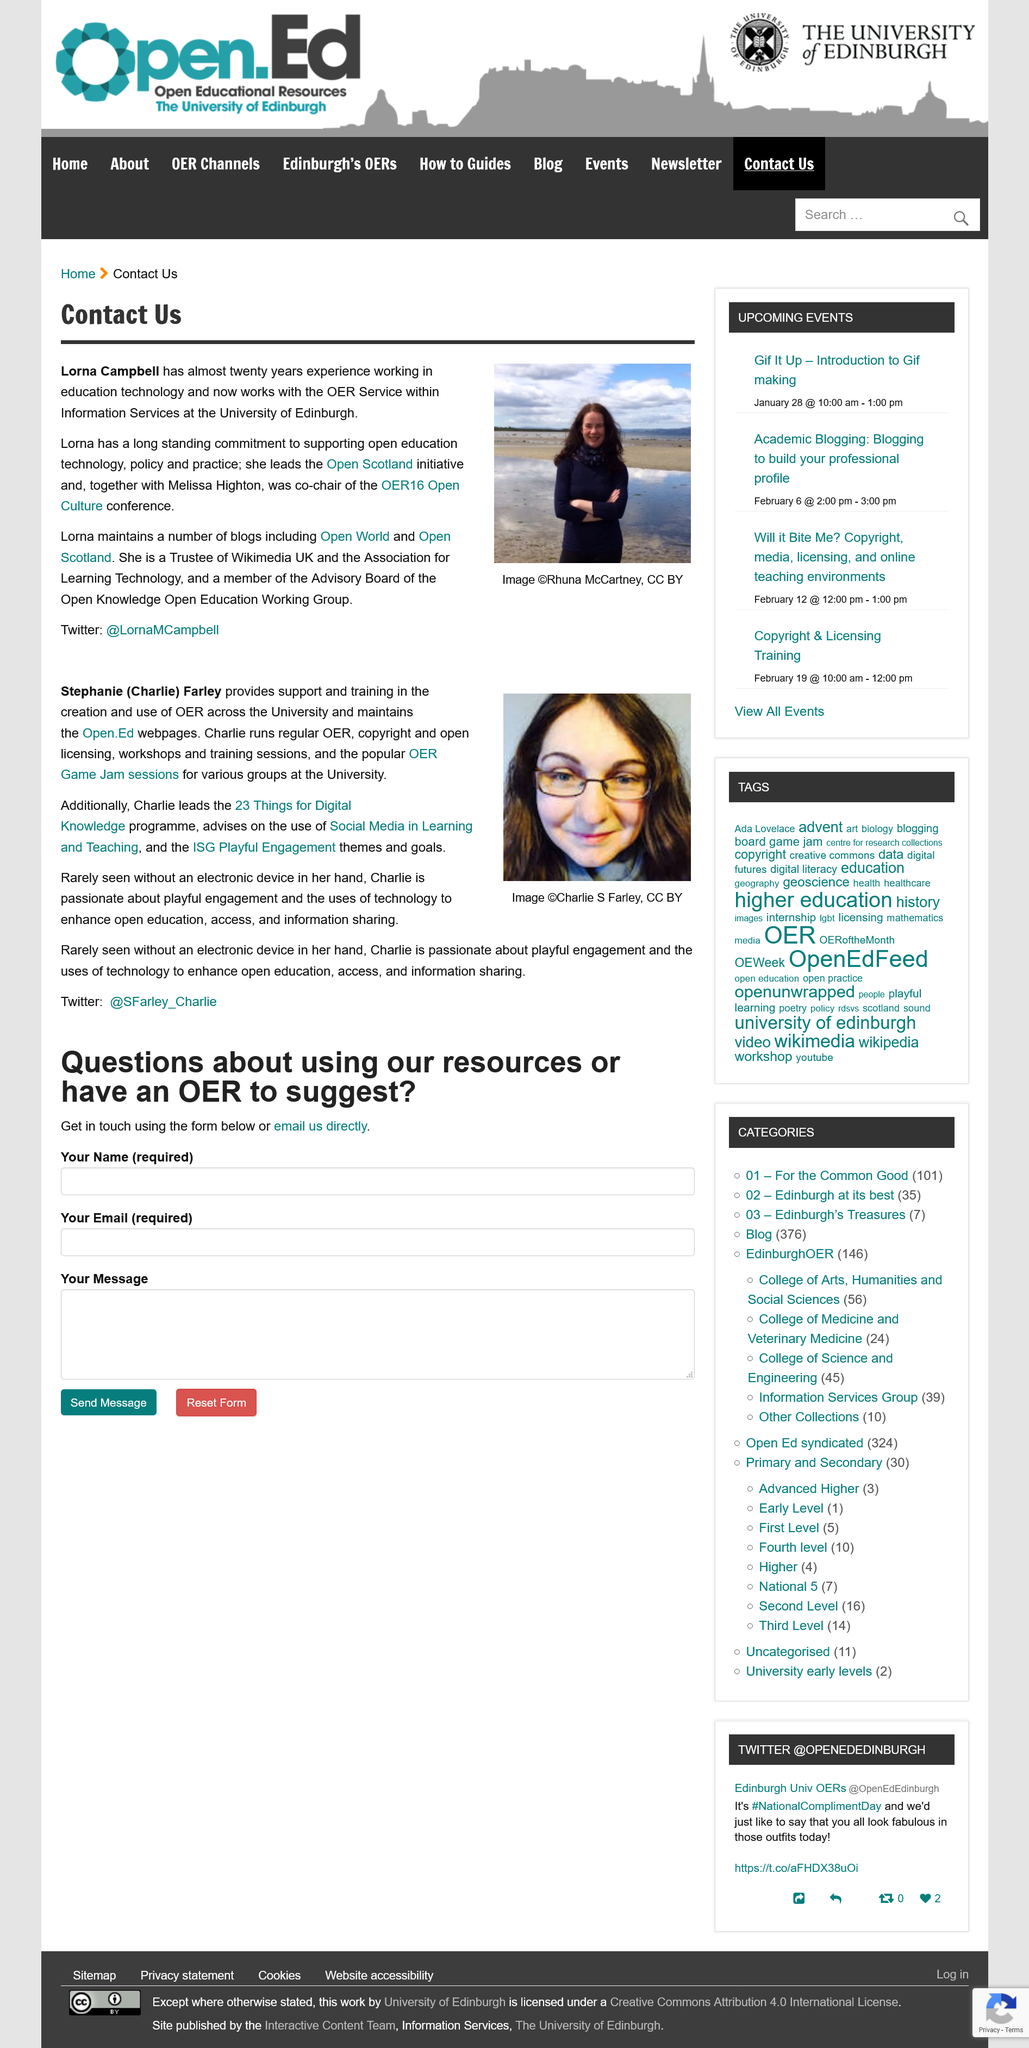Identify some key points in this picture. Charlie uses electronic devices. Lorna maintains the blog Is Open World. Lorna Campbell maintains multiple blogs and leads the Open Scotland initiative. Charlie provides training in the creation and use of open educational resources (OER) to support the development of high-quality, accessible educational materials for learners and institutions worldwide. The person depicted in the image is named Stephanie (Charlie) Farley. 